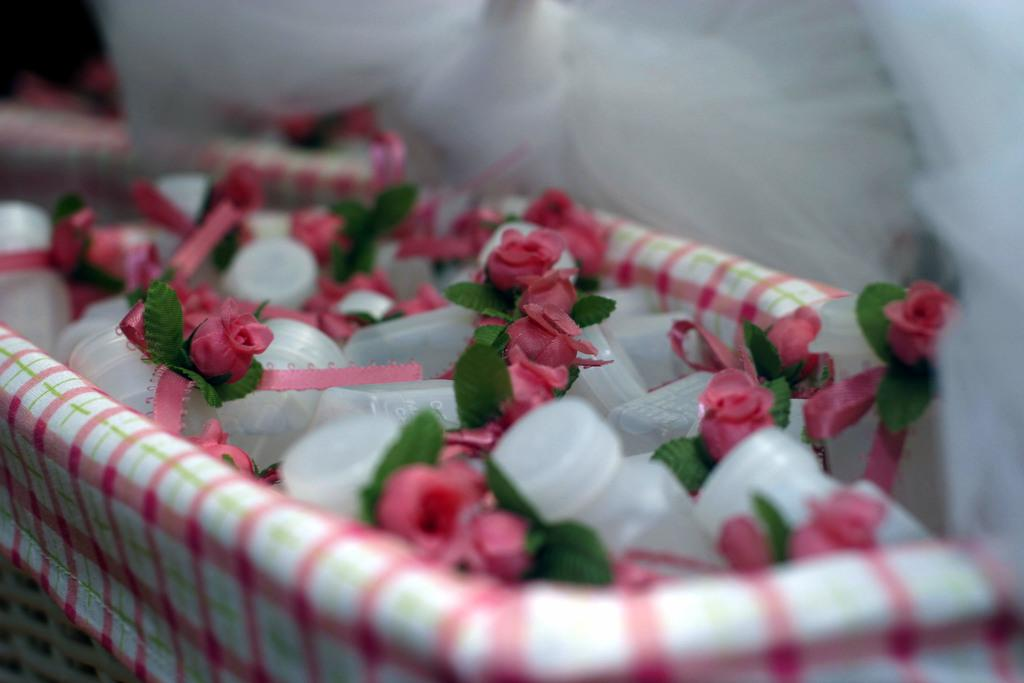What type of plants can be seen in the image? There are flowers in the image. What color are the flowers? The flowers are pink in color. What else is present in the image besides the flowers? There are bottles in the image. How are the bottles arranged or contained in the image? The bottles are in a basket. What colors are used for the basket? The basket is in white and pink color. What type of pleasure can be seen in the image? There is no indication of pleasure in the image; it features flowers, bottles, and a basket. Is there a cellar visible in the image? There is no cellar present in the image. 